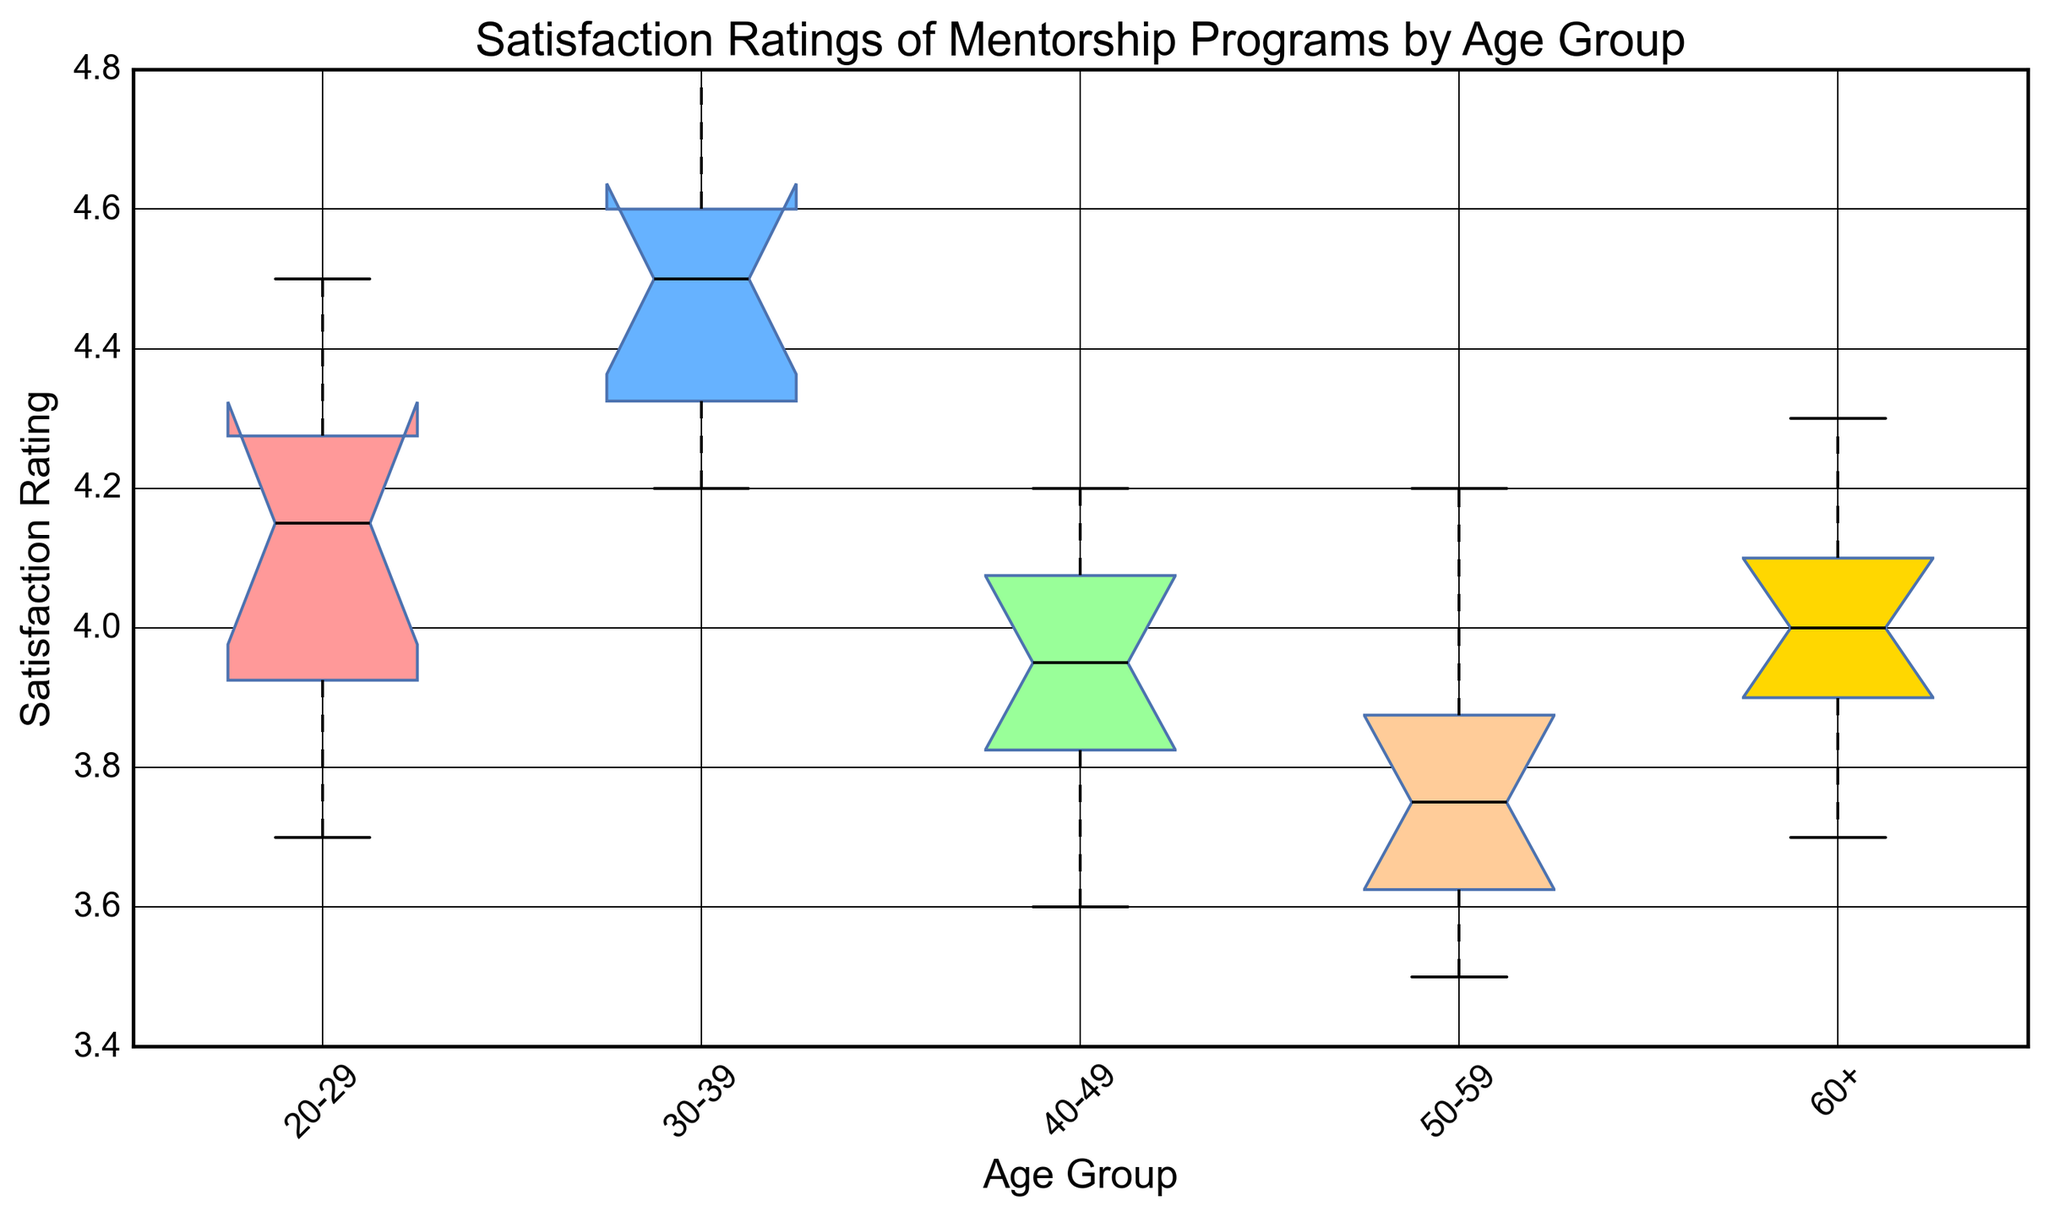What is the median satisfaction rating for the 20-29 age group? Locate the box corresponding to the 20-29 age group. The middle line within this box represents the median value.
Answer: 4.1 Which age group has the highest median satisfaction rating? Compare the positions of the median lines within each box for all age groups. The group with the highest median will have the median line furthest up the vertical axis.
Answer: 30-39 What is the interquartile range (IQR) for the 60+ age group? The IQR is the difference between the third quartile (Q3) and the first quartile (Q1). Read these values from the top and bottom edges of the box.
Answer: 4.1 - 3.9 = 0.2 Which age group has the widest range of satisfaction ratings? Identify which age group has the longest whiskers or farthest spread of fliers.
Answer: 30-39 Are there any outliers in the 40-49 age group? Look for any individual data points that fall outside the whiskers. These are typically marked by fliers (+) beyond the whiskers of the box plot.
Answer: No How do the interquartile ranges (IQRs) of the 40-49 and 50-59 age groups compare? Compute the IQR for each by subtracting the first quartile (Q1) from the third quartile (Q3) for both age groups, then compare the values.
Answer: 0.4 vs 0.4 Which age group shows the most variation in satisfaction ratings? Examine which box has the longest length between the first and third quartiles, indicative of greater variation within that group.
Answer: 30-39 Does any age group have the same median and first quartile (Q1) or third quartile (Q3)? Check if the line representing the median coincides with either the top or bottom edge of the box in any age group.
Answer: No How does the satisfaction rating distribution of the 20-29 age group compare visually to the 50-59 age group? Compare the positions and lengths of the boxes, whiskers, and any outliers to see visual differences in spread and central tendency.
Answer: 20-29 has higher and slightly wider distribution compared to 50-59 